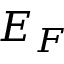<formula> <loc_0><loc_0><loc_500><loc_500>E _ { F }</formula> 